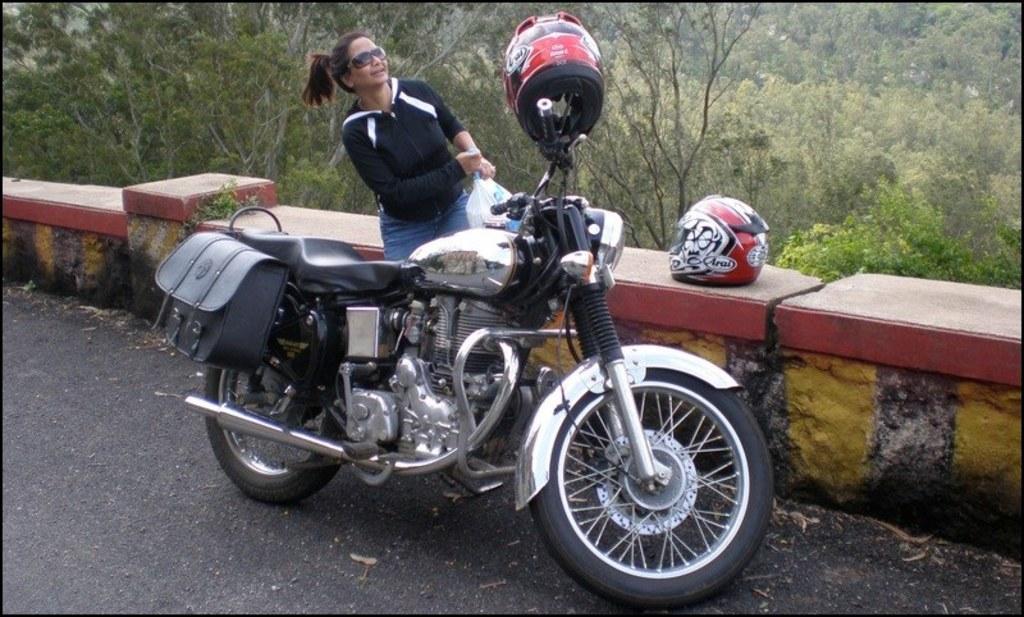Please provide a concise description of this image. In this image we can see a woman, bike, bag, plastic cover, and helmets. There is a road and a wall. In the background we can see trees. 